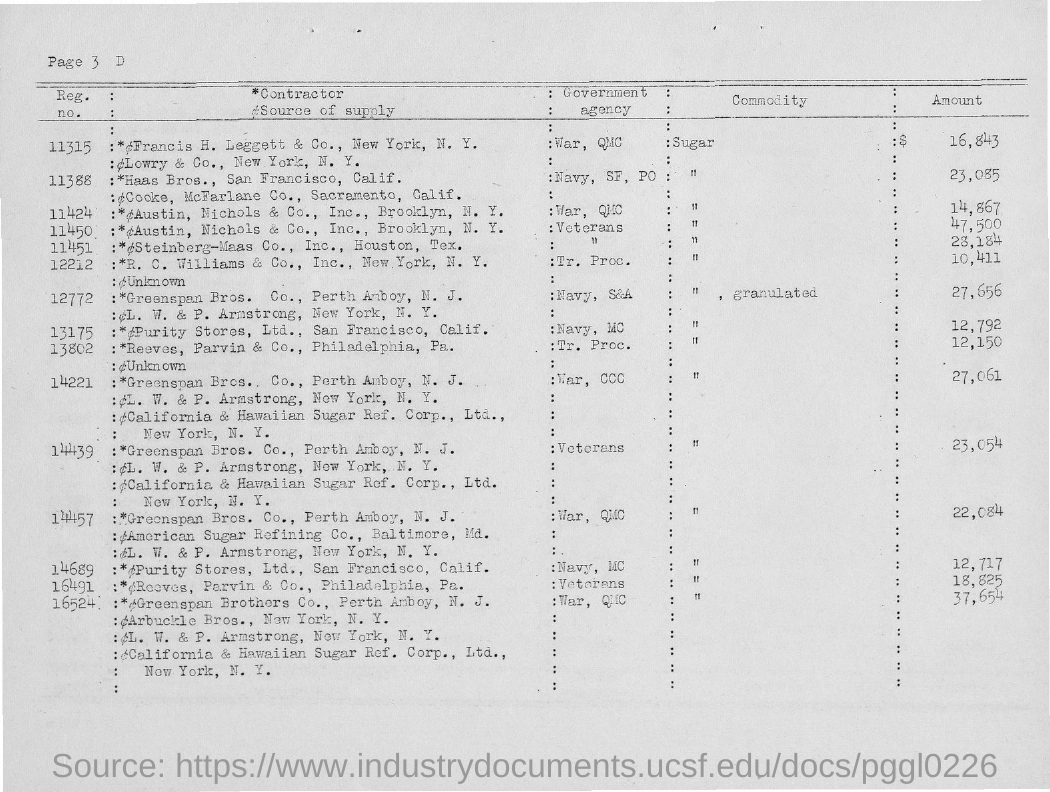Draw attention to some important aspects in this diagram. The amount of the commodity supplied by Haas Bros. is 23,085. The last registration number given on this page is 16524. Lowry & Co., New York, N.Y., supplies the government agency responsible for War and the QMC. The Haas Bros., located in San Francisco, California, supply their products to various government agencies, including the Navy and the San Francisco Port. The first Contractor mentioned in the table is Francis H. Leggett & Co., located in New York, New York. 